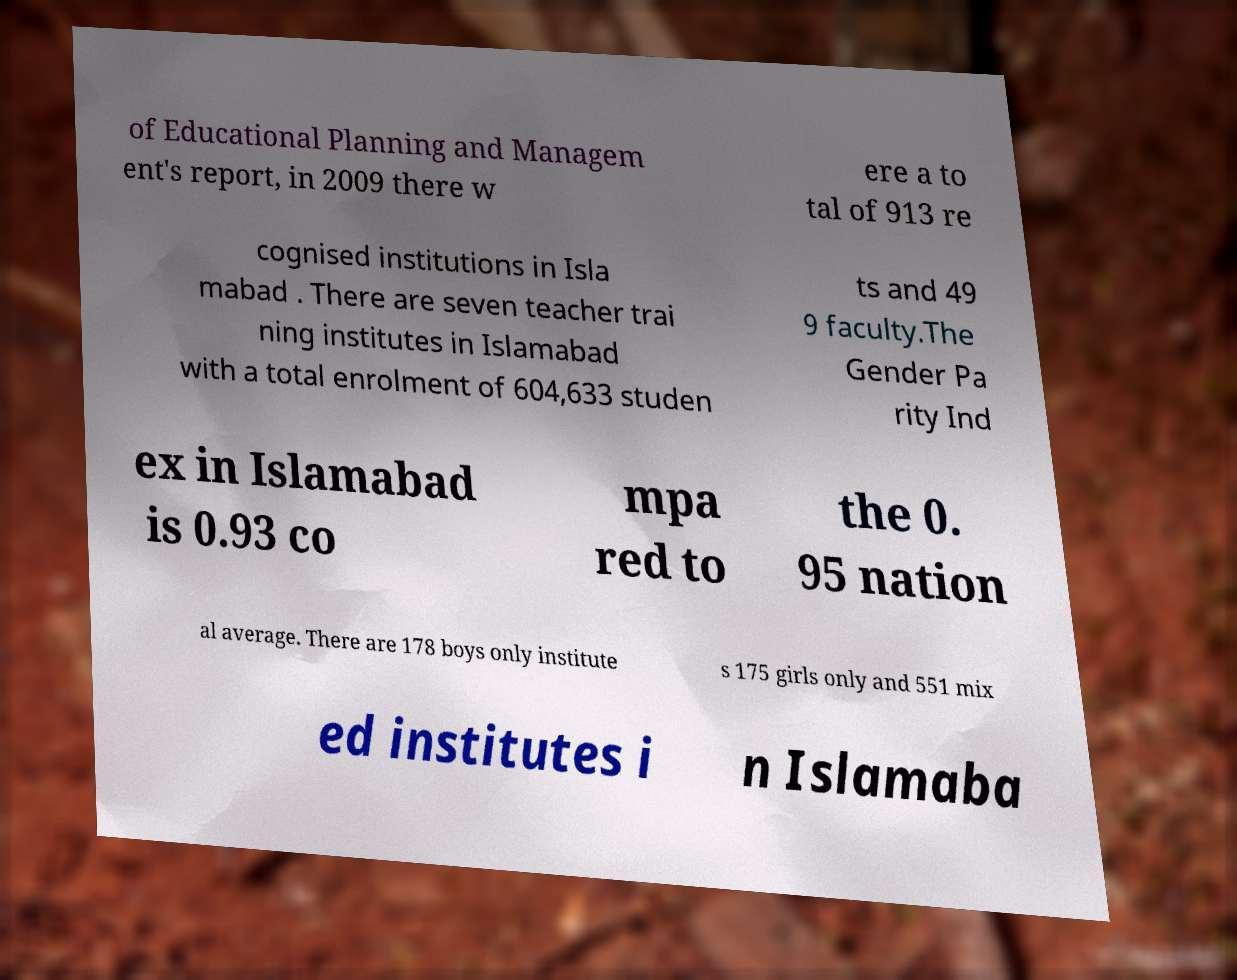Could you extract and type out the text from this image? of Educational Planning and Managem ent's report, in 2009 there w ere a to tal of 913 re cognised institutions in Isla mabad . There are seven teacher trai ning institutes in Islamabad with a total enrolment of 604,633 studen ts and 49 9 faculty.The Gender Pa rity Ind ex in Islamabad is 0.93 co mpa red to the 0. 95 nation al average. There are 178 boys only institute s 175 girls only and 551 mix ed institutes i n Islamaba 